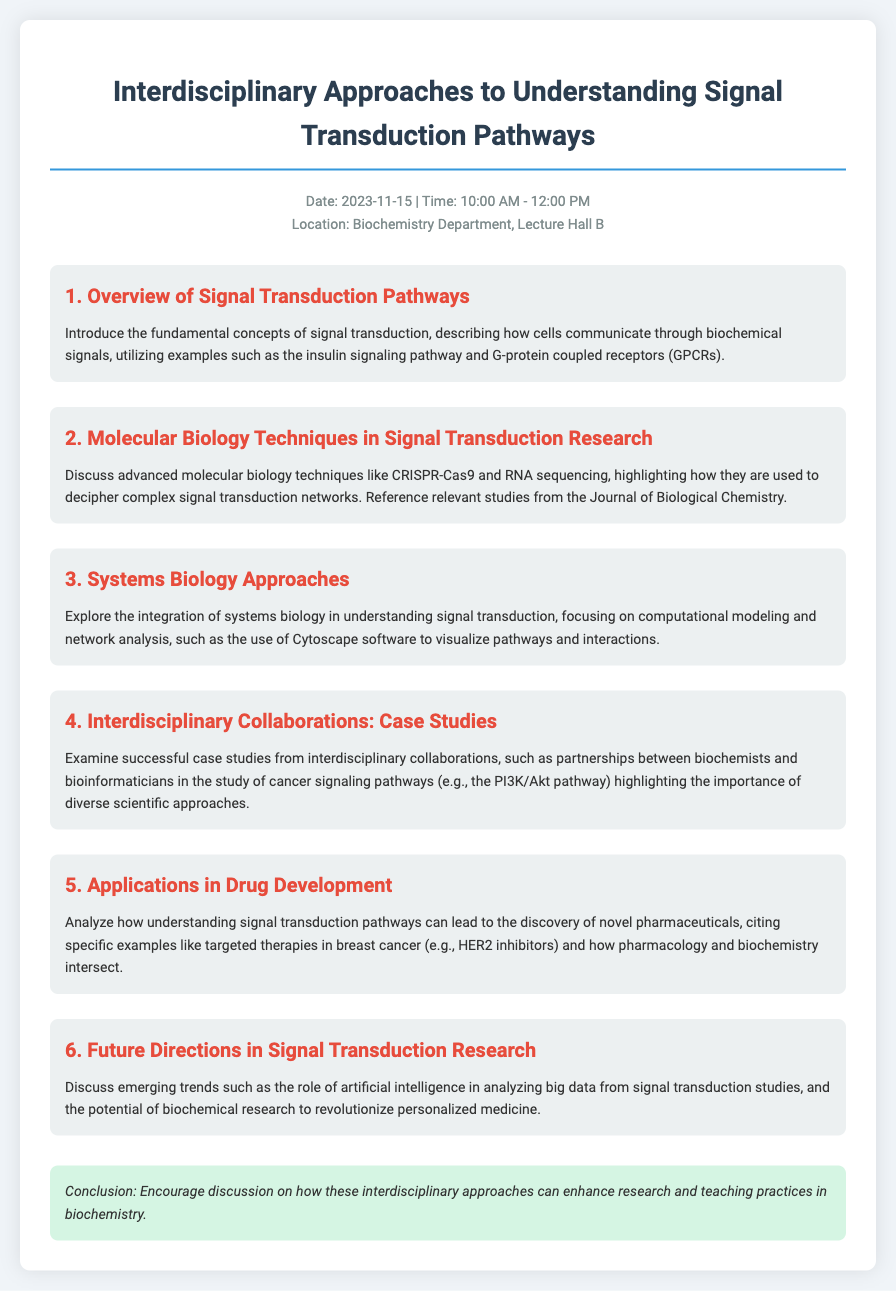What is the date of the event? The date is mentioned at the beginning of the document, which is November 15, 2023.
Answer: November 15, 2023 What is the time of the agenda? The time is specified in the header info section, which is from 10:00 AM to 12:00 PM.
Answer: 10:00 AM - 12:00 PM In which location will the event take place? The location is provided in the header information, specifically the Biochemistry Department, Lecture Hall B.
Answer: Biochemistry Department, Lecture Hall B What is the title of the second topic? The title of the second topic is stated in the document as "Molecular Biology Techniques in Signal Transduction Research."
Answer: Molecular Biology Techniques in Signal Transduction Research Which software is mentioned for visualizing pathways? The document includes a mention of Cytoscape software for visualizing pathways and interactions.
Answer: Cytoscape What is the main focus of the fifth topic? The main focus of the fifth topic is the applications of understanding signal transduction pathways in drug development.
Answer: Applications in Drug Development Which pathway is highlighted in the case studies of interdisciplinary collaborations? The case studies include the PI3K/Akt pathway as an example of interdisciplinary collaboration.
Answer: PI3K/Akt pathway What emerging trend is discussed in the last topic? The last topic discusses the role of artificial intelligence in analyzing big data from signal transduction studies.
Answer: Artificial intelligence What is encouraged in the conclusion? The conclusion encourages a discussion on enhancing research and teaching practices in biochemistry through interdisciplinary approaches.
Answer: Discussion on enhancing research and teaching practices 